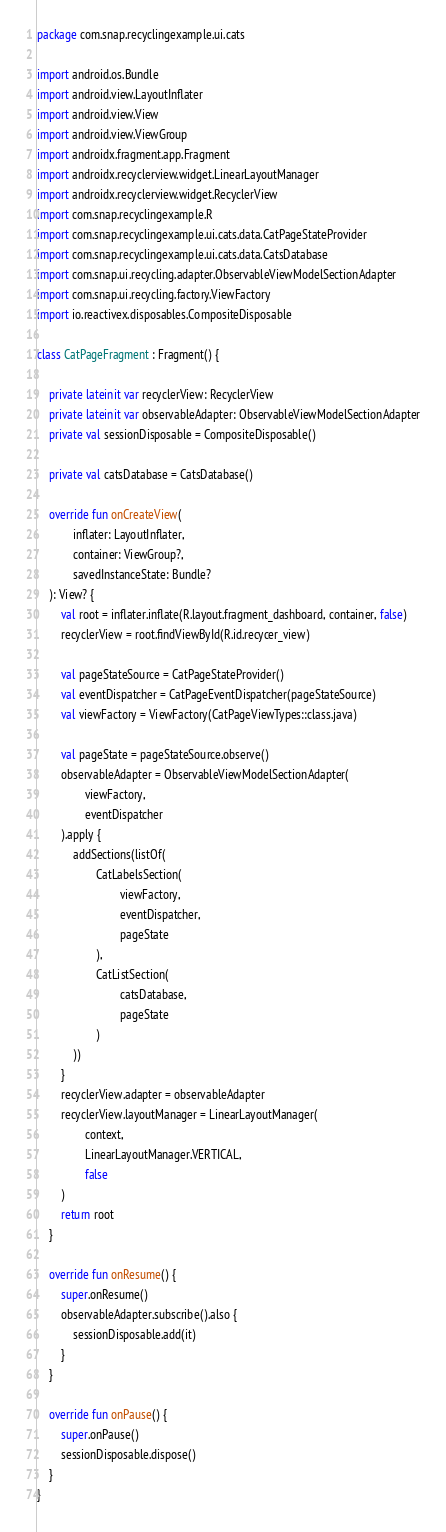<code> <loc_0><loc_0><loc_500><loc_500><_Kotlin_>package com.snap.recyclingexample.ui.cats

import android.os.Bundle
import android.view.LayoutInflater
import android.view.View
import android.view.ViewGroup
import androidx.fragment.app.Fragment
import androidx.recyclerview.widget.LinearLayoutManager
import androidx.recyclerview.widget.RecyclerView
import com.snap.recyclingexample.R
import com.snap.recyclingexample.ui.cats.data.CatPageStateProvider
import com.snap.recyclingexample.ui.cats.data.CatsDatabase
import com.snap.ui.recycling.adapter.ObservableViewModelSectionAdapter
import com.snap.ui.recycling.factory.ViewFactory
import io.reactivex.disposables.CompositeDisposable

class CatPageFragment : Fragment() {

    private lateinit var recyclerView: RecyclerView
    private lateinit var observableAdapter: ObservableViewModelSectionAdapter
    private val sessionDisposable = CompositeDisposable()

    private val catsDatabase = CatsDatabase()

    override fun onCreateView(
            inflater: LayoutInflater,
            container: ViewGroup?,
            savedInstanceState: Bundle?
    ): View? {
        val root = inflater.inflate(R.layout.fragment_dashboard, container, false)
        recyclerView = root.findViewById(R.id.recycer_view)

        val pageStateSource = CatPageStateProvider()
        val eventDispatcher = CatPageEventDispatcher(pageStateSource)
        val viewFactory = ViewFactory(CatPageViewTypes::class.java)

        val pageState = pageStateSource.observe()
        observableAdapter = ObservableViewModelSectionAdapter(
                viewFactory,
                eventDispatcher
        ).apply {
            addSections(listOf(
                    CatLabelsSection(
                            viewFactory,
                            eventDispatcher,
                            pageState
                    ),
                    CatListSection(
                            catsDatabase,
                            pageState
                    )
            ))
        }
        recyclerView.adapter = observableAdapter
        recyclerView.layoutManager = LinearLayoutManager(
                context,
                LinearLayoutManager.VERTICAL,
                false
        )
        return root
    }

    override fun onResume() {
        super.onResume()
        observableAdapter.subscribe().also {
            sessionDisposable.add(it)
        }
    }

    override fun onPause() {
        super.onPause()
        sessionDisposable.dispose()
    }
}
</code> 